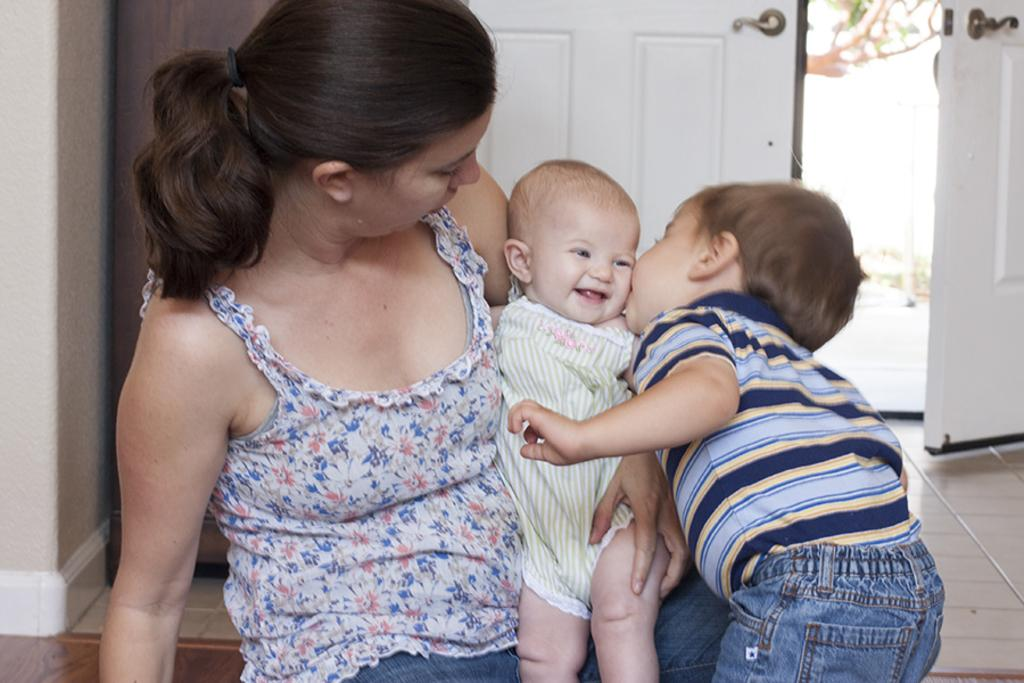Who is the main subject in the image? There is a woman in the image. What is the woman doing in the image? The woman is holding a baby. Who else is present in the image? There is a boy in the image. What is the boy doing in the image? The boy is kissing the baby. What can be seen in the background of the image? There is a white color door and a wall in the image. What type of clouds can be seen in the image? There are no clouds visible in the image. Can you tell me the color of the vein on the baby's forehead? There is no visible vein on the baby's forehead in the image. 